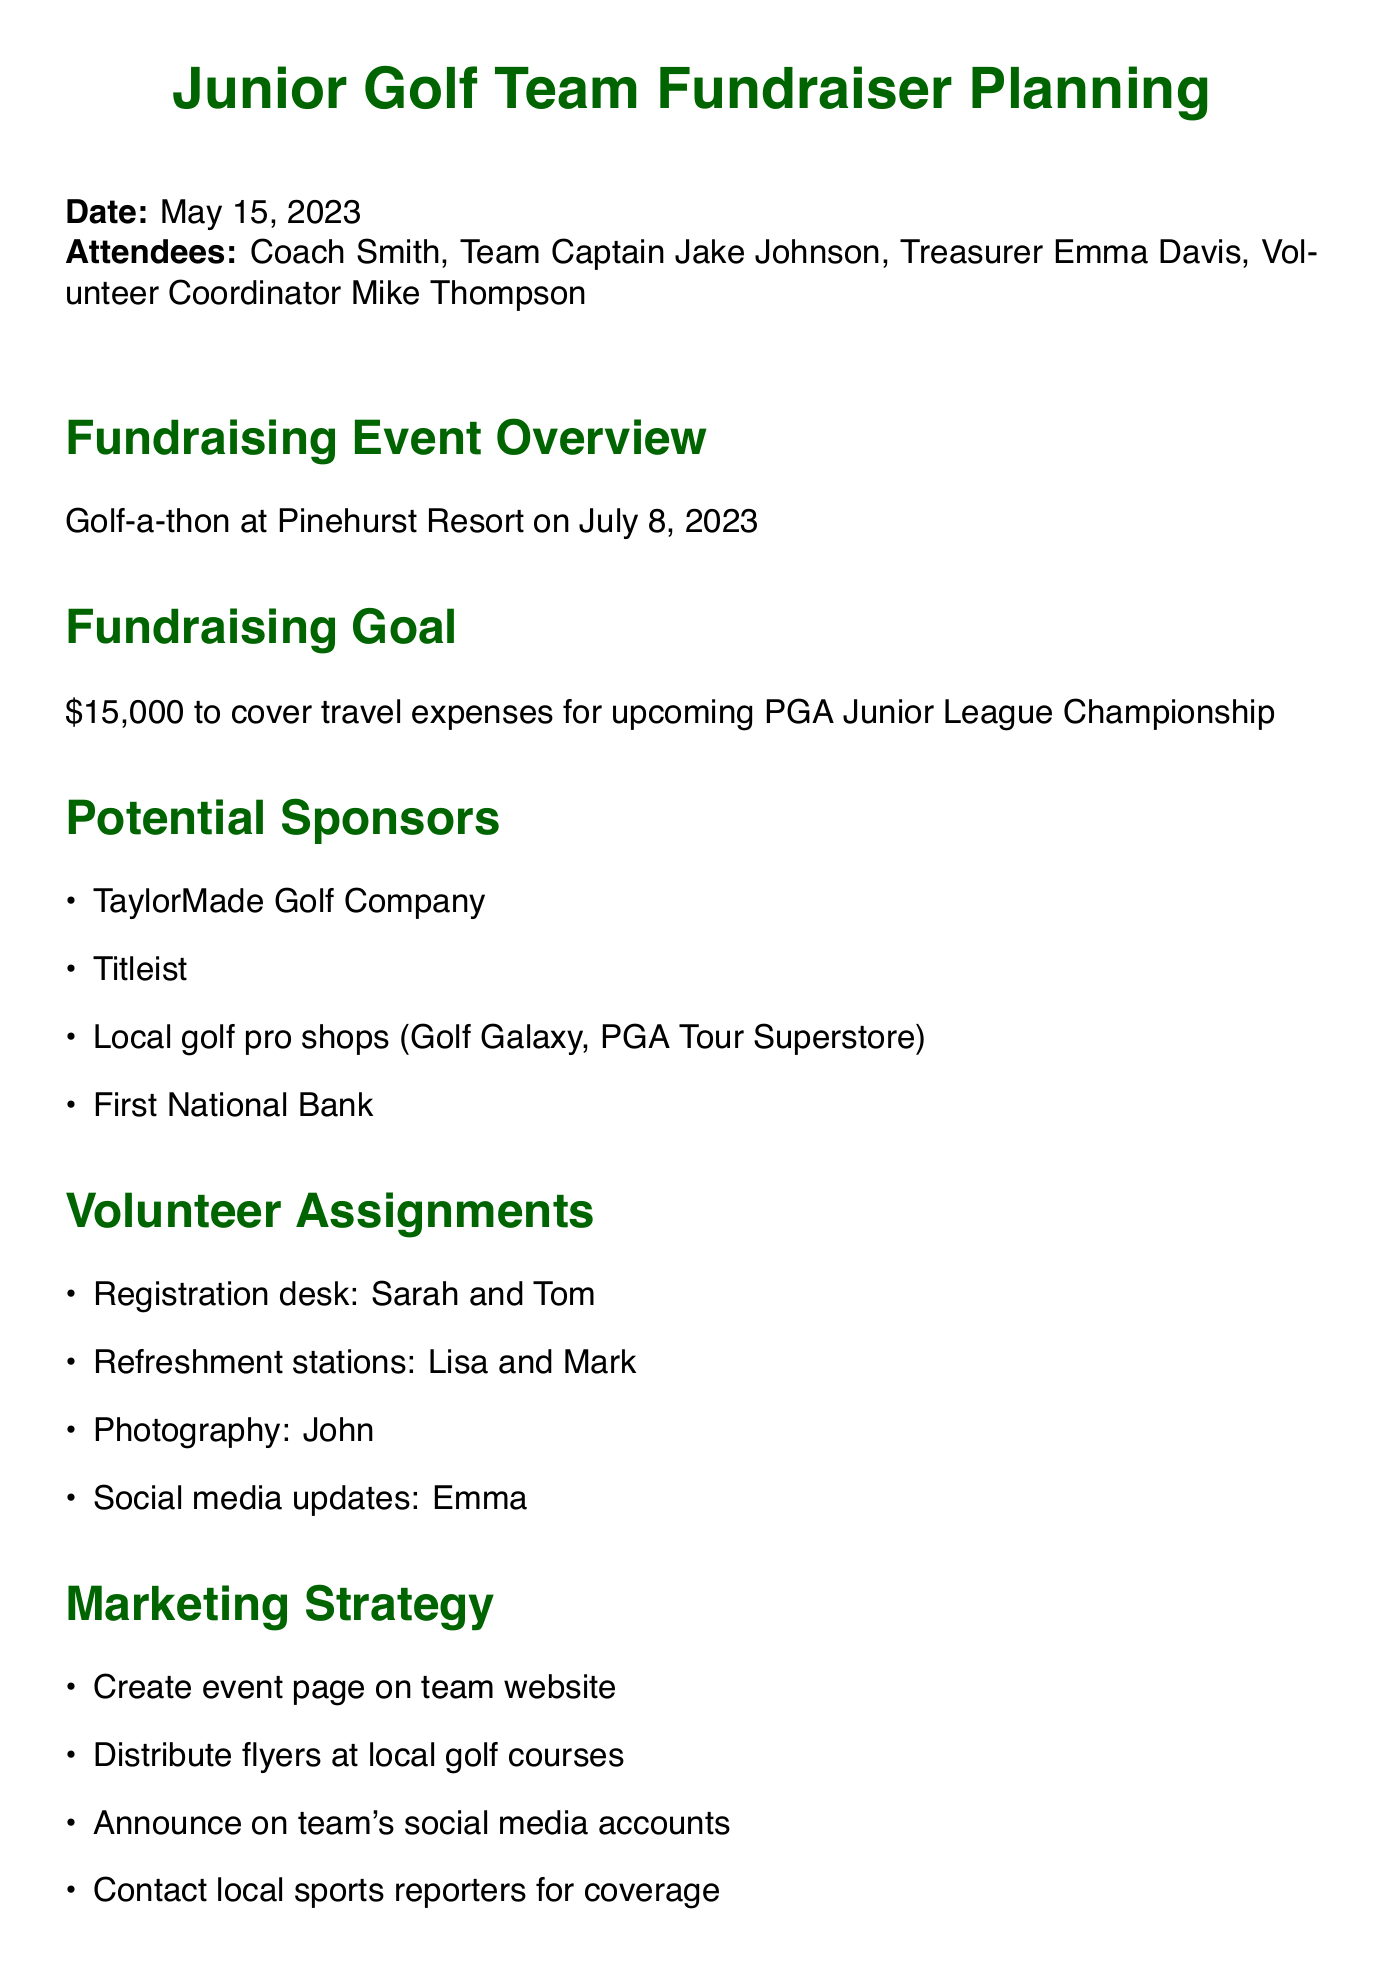What is the date of the meeting? The date of the meeting is stated explicitly in the document.
Answer: May 15, 2023 What is the fundraising goal? The document specifies the total amount needed for the fundraising event.
Answer: $15,000 Where will the golf-a-thon take place? The location of the fundraising event is mentioned in the overview section.
Answer: Pinehurst Resort Who is responsible for the registration desk? The volunteer assignments section lists those in charge of various roles.
Answer: Sarah and Tom Which company is listed as a potential sponsor related to golf equipment? The potential sponsors section includes names of companies that may provide sponsorships.
Answer: TaylorMade Golf Company What is the deadline to finalize the sponsor outreach list? The next steps section outlines specific deadlines for tasks related to the event.
Answer: May 20 Which marketing strategy involves team social media? The marketing strategy section highlights methods to promote the fundraising event.
Answer: Announce on team's social media accounts How many volunteer roles were assigned? The volunteer assignments section lists individuals assigned to specific roles, allowing for a count.
Answer: 4 